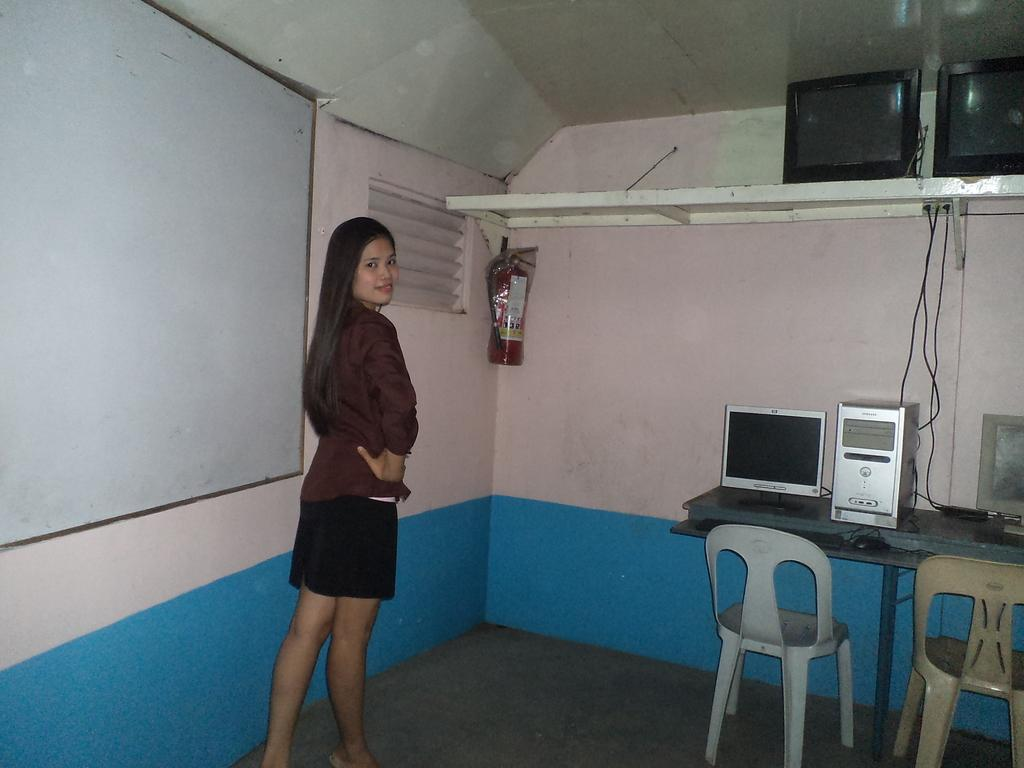Who is present in the image? There is a woman in the image. What is the woman wearing? The woman is wearing a brown shirt. What is the woman's posture in the image? The woman is standing. What object is in front of the woman? There is a table in front of the woman. What is on the table? The table has desktops on it. What is beside the woman? There is a whiteboard beside the woman. What is the color of the wall in the image? The wall is pink in color. What type of boats can be seen sailing in the background of the image? There are no boats visible in the image; it features a woman standing in front of a table with desktops and a whiteboard beside her. 